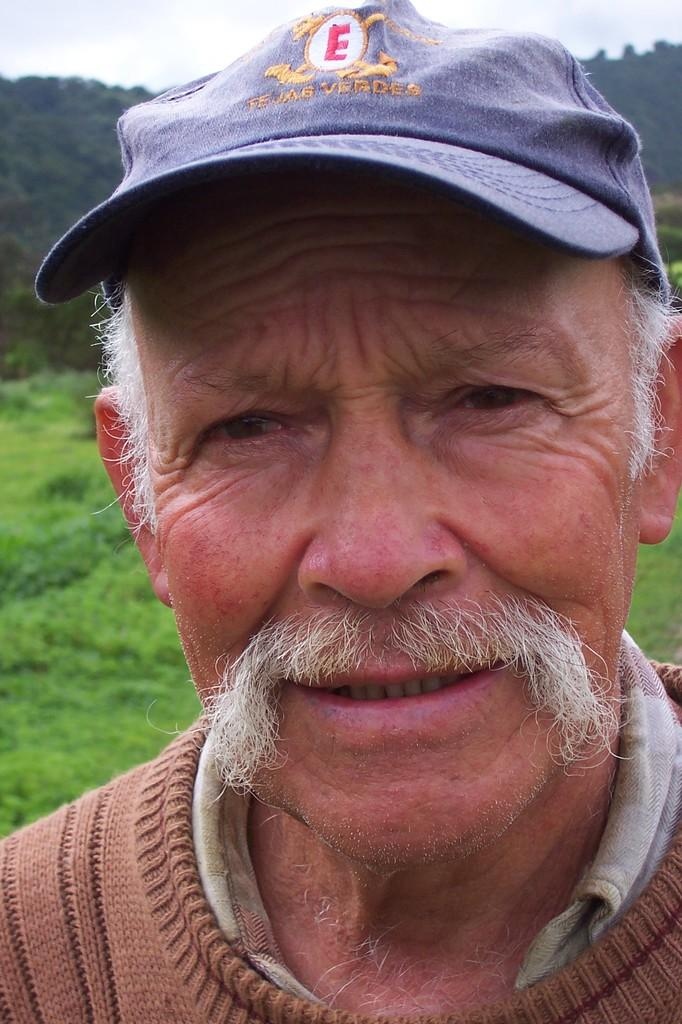Who is the main subject in the image? There is an old man in the image. What is the old man doing in the image? The old man is smiling. What clothing items is the old man wearing? The old man is wearing a sweater and a cap. What can be seen in the background of the image? There is grass visible in the background of the image, and the background appears to be hills. How much money is the old man holding in the image? There is no indication of money in the image; the old man is not holding any money. Is the queen present in the image? No, the queen is not present in the image; the main subject is an old man. 